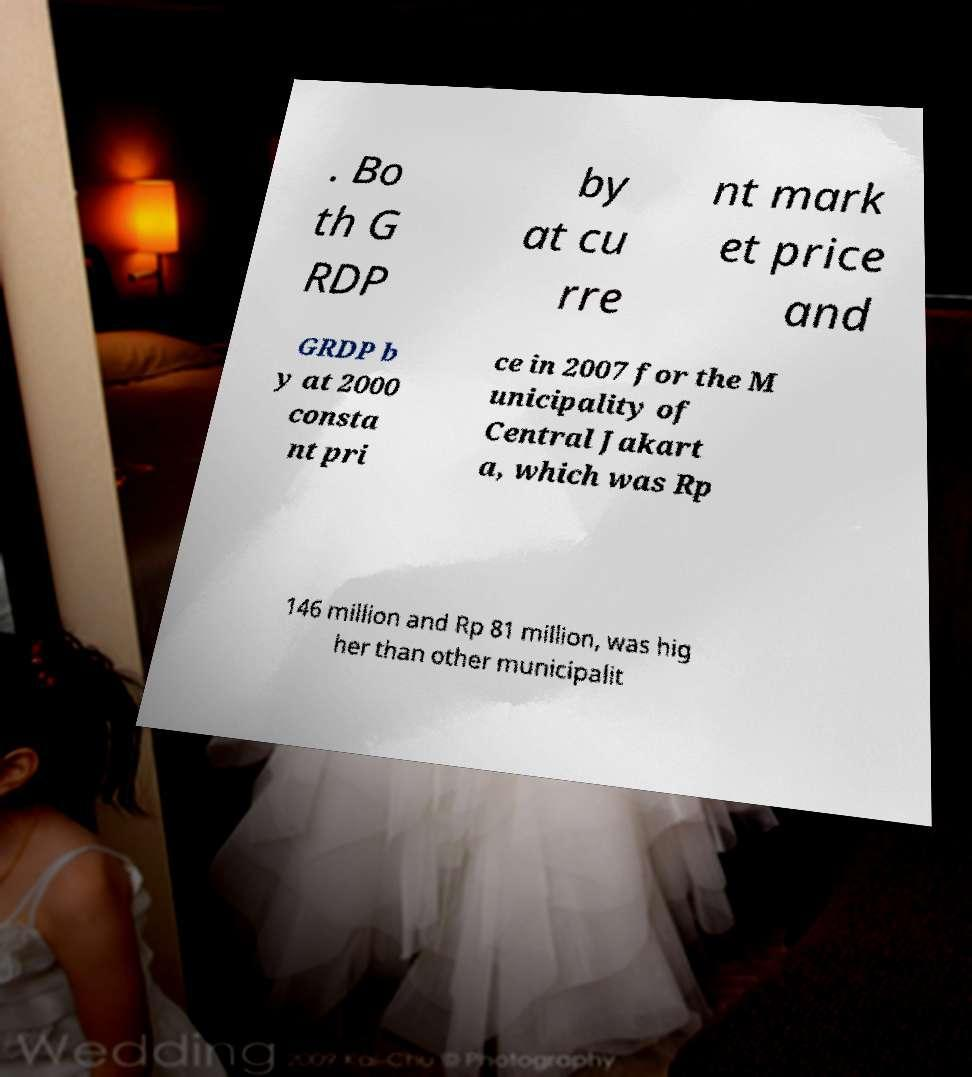Can you accurately transcribe the text from the provided image for me? . Bo th G RDP by at cu rre nt mark et price and GRDP b y at 2000 consta nt pri ce in 2007 for the M unicipality of Central Jakart a, which was Rp 146 million and Rp 81 million, was hig her than other municipalit 